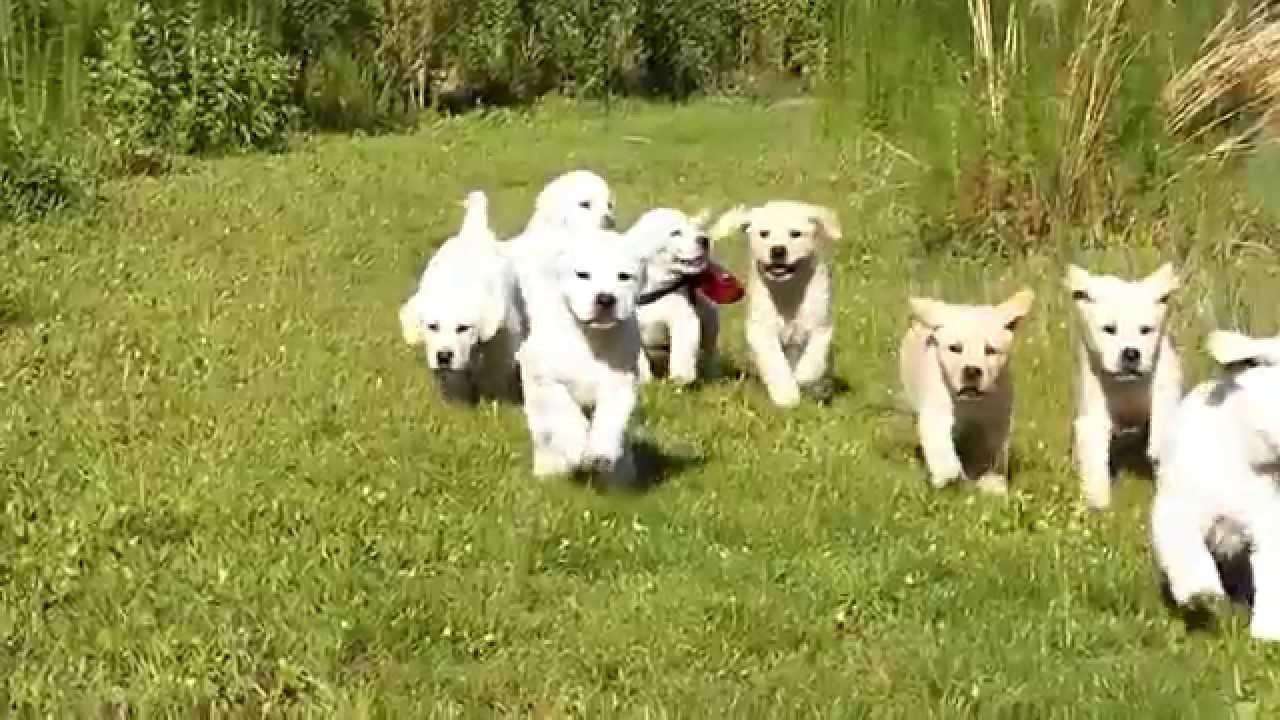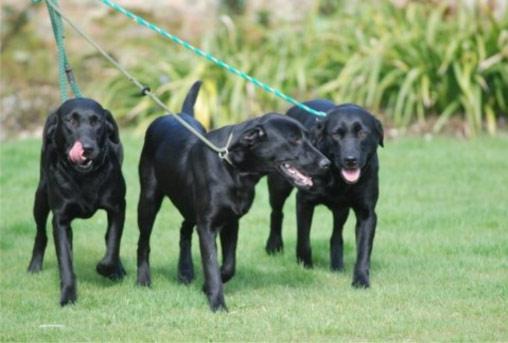The first image is the image on the left, the second image is the image on the right. For the images shown, is this caption "An image includes eight nearly white dogs of the same breed." true? Answer yes or no. Yes. 